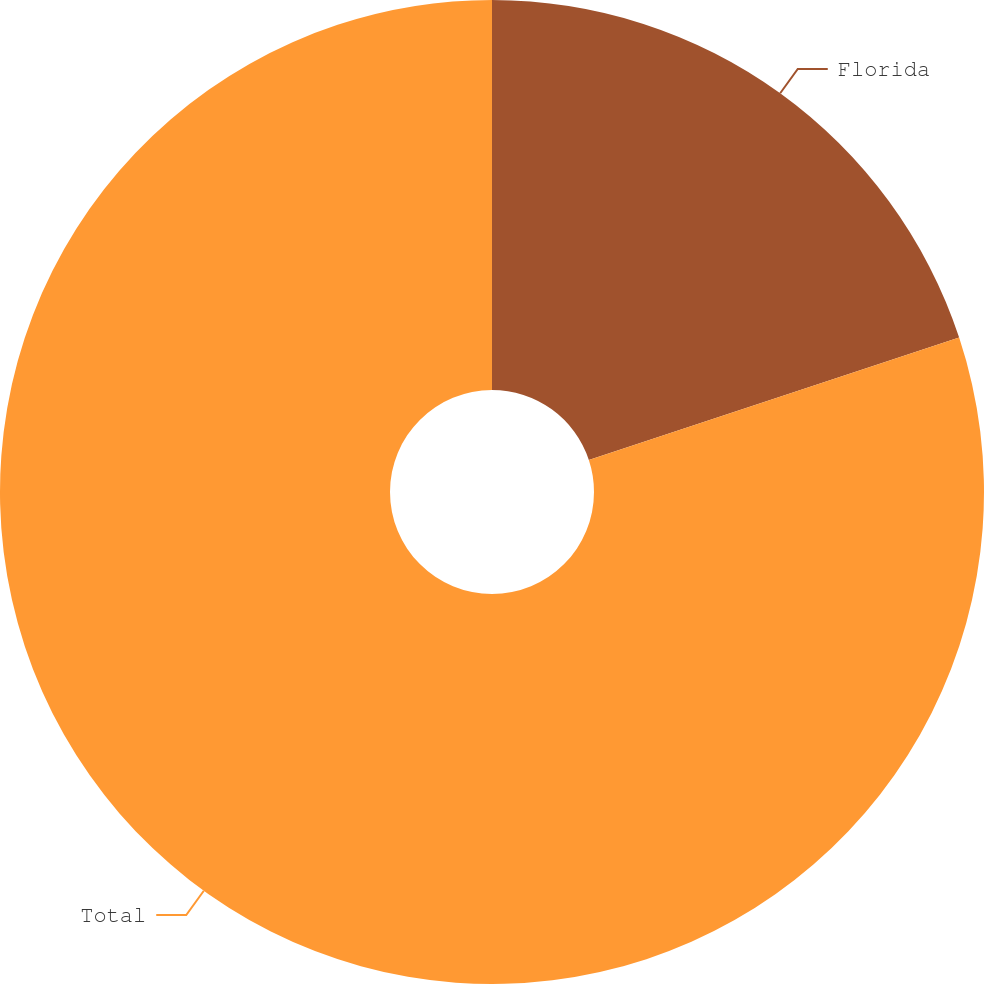<chart> <loc_0><loc_0><loc_500><loc_500><pie_chart><fcel>Florida<fcel>Total<nl><fcel>19.92%<fcel>80.08%<nl></chart> 